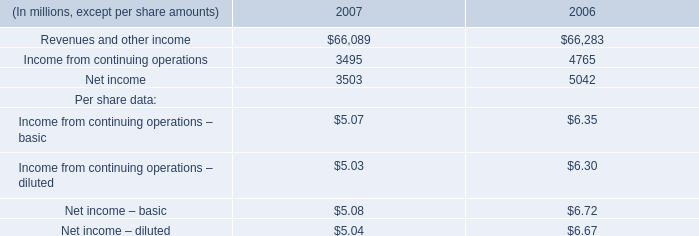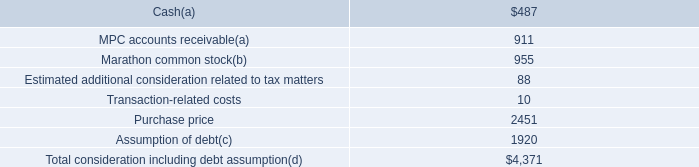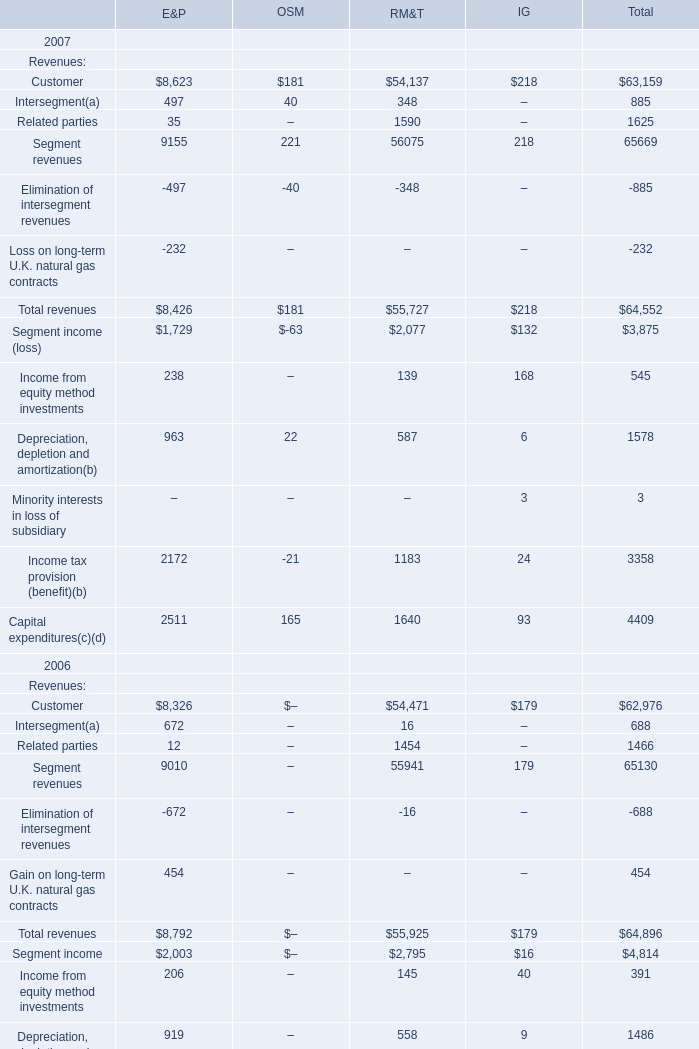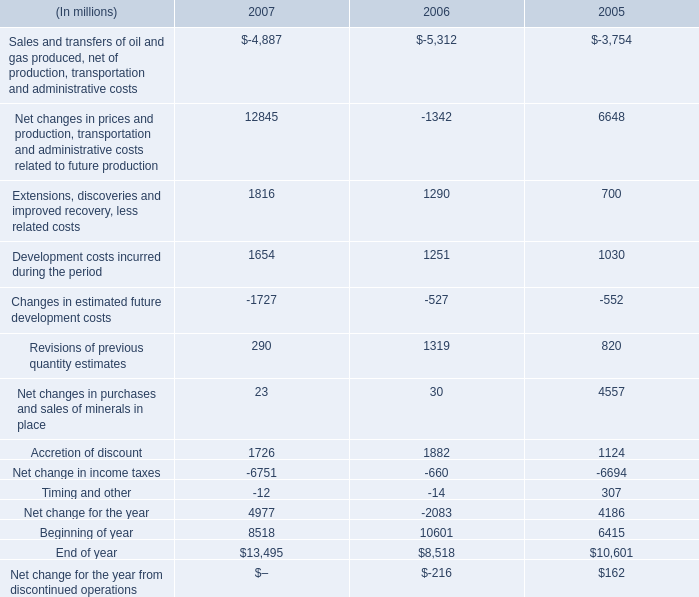What is the proportion of Segment revenues to the total in 2006 for Total revenues? 
Computations: (65130 / 64896)
Answer: 1.00361. 